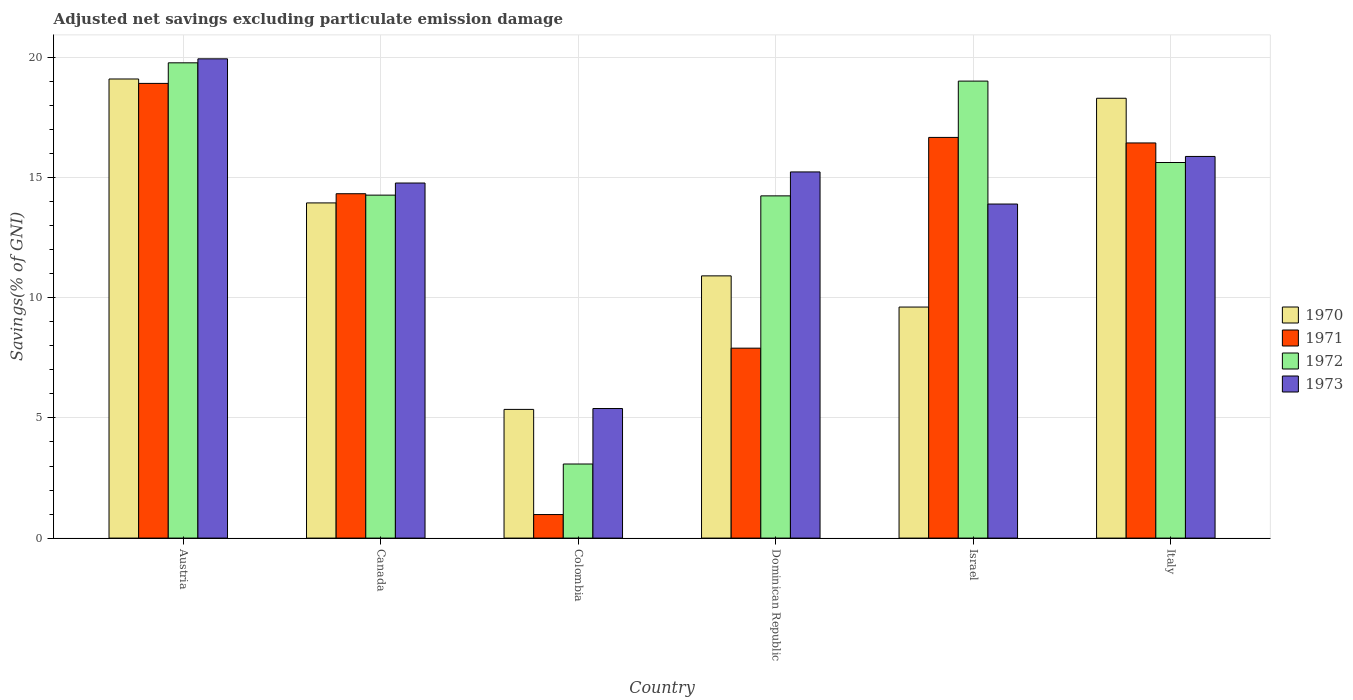How many groups of bars are there?
Ensure brevity in your answer.  6. Are the number of bars per tick equal to the number of legend labels?
Offer a very short reply. Yes. How many bars are there on the 5th tick from the right?
Offer a very short reply. 4. What is the label of the 3rd group of bars from the left?
Offer a terse response. Colombia. What is the adjusted net savings in 1973 in Canada?
Your answer should be very brief. 14.78. Across all countries, what is the maximum adjusted net savings in 1972?
Provide a succinct answer. 19.78. Across all countries, what is the minimum adjusted net savings in 1971?
Your response must be concise. 0.98. In which country was the adjusted net savings in 1973 maximum?
Make the answer very short. Austria. In which country was the adjusted net savings in 1971 minimum?
Offer a terse response. Colombia. What is the total adjusted net savings in 1973 in the graph?
Offer a terse response. 85.14. What is the difference between the adjusted net savings in 1971 in Austria and that in Italy?
Keep it short and to the point. 2.48. What is the difference between the adjusted net savings in 1973 in Canada and the adjusted net savings in 1970 in Italy?
Give a very brief answer. -3.53. What is the average adjusted net savings in 1972 per country?
Make the answer very short. 14.34. What is the difference between the adjusted net savings of/in 1973 and adjusted net savings of/in 1972 in Israel?
Provide a succinct answer. -5.12. In how many countries, is the adjusted net savings in 1972 greater than 6 %?
Give a very brief answer. 5. What is the ratio of the adjusted net savings in 1973 in Dominican Republic to that in Israel?
Your response must be concise. 1.1. What is the difference between the highest and the second highest adjusted net savings in 1972?
Make the answer very short. -0.76. What is the difference between the highest and the lowest adjusted net savings in 1973?
Offer a very short reply. 14.55. In how many countries, is the adjusted net savings in 1972 greater than the average adjusted net savings in 1972 taken over all countries?
Offer a terse response. 3. Is it the case that in every country, the sum of the adjusted net savings in 1972 and adjusted net savings in 1970 is greater than the sum of adjusted net savings in 1971 and adjusted net savings in 1973?
Give a very brief answer. No. What does the 4th bar from the right in Israel represents?
Your answer should be compact. 1970. How many bars are there?
Provide a succinct answer. 24. Are all the bars in the graph horizontal?
Offer a terse response. No. Are the values on the major ticks of Y-axis written in scientific E-notation?
Ensure brevity in your answer.  No. What is the title of the graph?
Offer a terse response. Adjusted net savings excluding particulate emission damage. Does "1982" appear as one of the legend labels in the graph?
Keep it short and to the point. No. What is the label or title of the X-axis?
Make the answer very short. Country. What is the label or title of the Y-axis?
Offer a terse response. Savings(% of GNI). What is the Savings(% of GNI) of 1970 in Austria?
Provide a short and direct response. 19.11. What is the Savings(% of GNI) of 1971 in Austria?
Offer a very short reply. 18.92. What is the Savings(% of GNI) in 1972 in Austria?
Make the answer very short. 19.78. What is the Savings(% of GNI) in 1973 in Austria?
Keep it short and to the point. 19.94. What is the Savings(% of GNI) of 1970 in Canada?
Provide a succinct answer. 13.95. What is the Savings(% of GNI) in 1971 in Canada?
Your answer should be very brief. 14.33. What is the Savings(% of GNI) of 1972 in Canada?
Offer a very short reply. 14.27. What is the Savings(% of GNI) of 1973 in Canada?
Provide a short and direct response. 14.78. What is the Savings(% of GNI) of 1970 in Colombia?
Offer a terse response. 5.36. What is the Savings(% of GNI) in 1971 in Colombia?
Offer a terse response. 0.98. What is the Savings(% of GNI) in 1972 in Colombia?
Give a very brief answer. 3.08. What is the Savings(% of GNI) of 1973 in Colombia?
Provide a short and direct response. 5.39. What is the Savings(% of GNI) of 1970 in Dominican Republic?
Provide a short and direct response. 10.91. What is the Savings(% of GNI) of 1971 in Dominican Republic?
Offer a very short reply. 7.9. What is the Savings(% of GNI) in 1972 in Dominican Republic?
Provide a succinct answer. 14.24. What is the Savings(% of GNI) in 1973 in Dominican Republic?
Your answer should be compact. 15.24. What is the Savings(% of GNI) in 1970 in Israel?
Your answer should be compact. 9.61. What is the Savings(% of GNI) of 1971 in Israel?
Your answer should be very brief. 16.67. What is the Savings(% of GNI) in 1972 in Israel?
Provide a short and direct response. 19.02. What is the Savings(% of GNI) in 1973 in Israel?
Offer a very short reply. 13.9. What is the Savings(% of GNI) in 1970 in Italy?
Ensure brevity in your answer.  18.3. What is the Savings(% of GNI) in 1971 in Italy?
Make the answer very short. 16.44. What is the Savings(% of GNI) of 1972 in Italy?
Give a very brief answer. 15.63. What is the Savings(% of GNI) of 1973 in Italy?
Make the answer very short. 15.88. Across all countries, what is the maximum Savings(% of GNI) in 1970?
Keep it short and to the point. 19.11. Across all countries, what is the maximum Savings(% of GNI) in 1971?
Provide a short and direct response. 18.92. Across all countries, what is the maximum Savings(% of GNI) of 1972?
Provide a succinct answer. 19.78. Across all countries, what is the maximum Savings(% of GNI) in 1973?
Give a very brief answer. 19.94. Across all countries, what is the minimum Savings(% of GNI) of 1970?
Ensure brevity in your answer.  5.36. Across all countries, what is the minimum Savings(% of GNI) of 1971?
Give a very brief answer. 0.98. Across all countries, what is the minimum Savings(% of GNI) in 1972?
Your answer should be compact. 3.08. Across all countries, what is the minimum Savings(% of GNI) of 1973?
Provide a short and direct response. 5.39. What is the total Savings(% of GNI) of 1970 in the graph?
Keep it short and to the point. 77.24. What is the total Savings(% of GNI) in 1971 in the graph?
Your response must be concise. 75.25. What is the total Savings(% of GNI) in 1972 in the graph?
Offer a very short reply. 86.02. What is the total Savings(% of GNI) in 1973 in the graph?
Offer a very short reply. 85.14. What is the difference between the Savings(% of GNI) in 1970 in Austria and that in Canada?
Make the answer very short. 5.16. What is the difference between the Savings(% of GNI) in 1971 in Austria and that in Canada?
Give a very brief answer. 4.59. What is the difference between the Savings(% of GNI) of 1972 in Austria and that in Canada?
Offer a terse response. 5.51. What is the difference between the Savings(% of GNI) of 1973 in Austria and that in Canada?
Provide a succinct answer. 5.17. What is the difference between the Savings(% of GNI) of 1970 in Austria and that in Colombia?
Ensure brevity in your answer.  13.75. What is the difference between the Savings(% of GNI) in 1971 in Austria and that in Colombia?
Your answer should be very brief. 17.94. What is the difference between the Savings(% of GNI) in 1972 in Austria and that in Colombia?
Ensure brevity in your answer.  16.7. What is the difference between the Savings(% of GNI) in 1973 in Austria and that in Colombia?
Provide a short and direct response. 14.55. What is the difference between the Savings(% of GNI) of 1970 in Austria and that in Dominican Republic?
Offer a very short reply. 8.19. What is the difference between the Savings(% of GNI) of 1971 in Austria and that in Dominican Republic?
Your answer should be compact. 11.02. What is the difference between the Savings(% of GNI) of 1972 in Austria and that in Dominican Republic?
Your answer should be very brief. 5.54. What is the difference between the Savings(% of GNI) of 1973 in Austria and that in Dominican Republic?
Provide a short and direct response. 4.71. What is the difference between the Savings(% of GNI) in 1970 in Austria and that in Israel?
Make the answer very short. 9.49. What is the difference between the Savings(% of GNI) of 1971 in Austria and that in Israel?
Your response must be concise. 2.25. What is the difference between the Savings(% of GNI) of 1972 in Austria and that in Israel?
Make the answer very short. 0.76. What is the difference between the Savings(% of GNI) of 1973 in Austria and that in Israel?
Your response must be concise. 6.04. What is the difference between the Savings(% of GNI) of 1970 in Austria and that in Italy?
Provide a short and direct response. 0.8. What is the difference between the Savings(% of GNI) of 1971 in Austria and that in Italy?
Ensure brevity in your answer.  2.48. What is the difference between the Savings(% of GNI) of 1972 in Austria and that in Italy?
Keep it short and to the point. 4.15. What is the difference between the Savings(% of GNI) of 1973 in Austria and that in Italy?
Provide a short and direct response. 4.06. What is the difference between the Savings(% of GNI) in 1970 in Canada and that in Colombia?
Your response must be concise. 8.59. What is the difference between the Savings(% of GNI) in 1971 in Canada and that in Colombia?
Provide a short and direct response. 13.35. What is the difference between the Savings(% of GNI) in 1972 in Canada and that in Colombia?
Provide a succinct answer. 11.19. What is the difference between the Savings(% of GNI) in 1973 in Canada and that in Colombia?
Offer a terse response. 9.38. What is the difference between the Savings(% of GNI) in 1970 in Canada and that in Dominican Republic?
Provide a short and direct response. 3.04. What is the difference between the Savings(% of GNI) in 1971 in Canada and that in Dominican Republic?
Give a very brief answer. 6.43. What is the difference between the Savings(% of GNI) of 1972 in Canada and that in Dominican Republic?
Make the answer very short. 0.03. What is the difference between the Savings(% of GNI) of 1973 in Canada and that in Dominican Republic?
Your response must be concise. -0.46. What is the difference between the Savings(% of GNI) in 1970 in Canada and that in Israel?
Your response must be concise. 4.33. What is the difference between the Savings(% of GNI) in 1971 in Canada and that in Israel?
Give a very brief answer. -2.34. What is the difference between the Savings(% of GNI) in 1972 in Canada and that in Israel?
Ensure brevity in your answer.  -4.75. What is the difference between the Savings(% of GNI) of 1973 in Canada and that in Israel?
Provide a succinct answer. 0.87. What is the difference between the Savings(% of GNI) in 1970 in Canada and that in Italy?
Your response must be concise. -4.36. What is the difference between the Savings(% of GNI) of 1971 in Canada and that in Italy?
Keep it short and to the point. -2.11. What is the difference between the Savings(% of GNI) in 1972 in Canada and that in Italy?
Offer a terse response. -1.36. What is the difference between the Savings(% of GNI) of 1973 in Canada and that in Italy?
Your response must be concise. -1.11. What is the difference between the Savings(% of GNI) in 1970 in Colombia and that in Dominican Republic?
Provide a short and direct response. -5.56. What is the difference between the Savings(% of GNI) in 1971 in Colombia and that in Dominican Republic?
Offer a terse response. -6.92. What is the difference between the Savings(% of GNI) of 1972 in Colombia and that in Dominican Republic?
Make the answer very short. -11.16. What is the difference between the Savings(% of GNI) in 1973 in Colombia and that in Dominican Republic?
Ensure brevity in your answer.  -9.85. What is the difference between the Savings(% of GNI) of 1970 in Colombia and that in Israel?
Provide a short and direct response. -4.26. What is the difference between the Savings(% of GNI) of 1971 in Colombia and that in Israel?
Your response must be concise. -15.7. What is the difference between the Savings(% of GNI) in 1972 in Colombia and that in Israel?
Provide a succinct answer. -15.94. What is the difference between the Savings(% of GNI) in 1973 in Colombia and that in Israel?
Ensure brevity in your answer.  -8.51. What is the difference between the Savings(% of GNI) of 1970 in Colombia and that in Italy?
Provide a succinct answer. -12.95. What is the difference between the Savings(% of GNI) of 1971 in Colombia and that in Italy?
Provide a short and direct response. -15.46. What is the difference between the Savings(% of GNI) of 1972 in Colombia and that in Italy?
Give a very brief answer. -12.55. What is the difference between the Savings(% of GNI) in 1973 in Colombia and that in Italy?
Your response must be concise. -10.49. What is the difference between the Savings(% of GNI) of 1970 in Dominican Republic and that in Israel?
Offer a terse response. 1.3. What is the difference between the Savings(% of GNI) of 1971 in Dominican Republic and that in Israel?
Make the answer very short. -8.77. What is the difference between the Savings(% of GNI) in 1972 in Dominican Republic and that in Israel?
Offer a very short reply. -4.78. What is the difference between the Savings(% of GNI) in 1973 in Dominican Republic and that in Israel?
Ensure brevity in your answer.  1.34. What is the difference between the Savings(% of GNI) of 1970 in Dominican Republic and that in Italy?
Keep it short and to the point. -7.39. What is the difference between the Savings(% of GNI) of 1971 in Dominican Republic and that in Italy?
Offer a very short reply. -8.54. What is the difference between the Savings(% of GNI) of 1972 in Dominican Republic and that in Italy?
Your answer should be compact. -1.39. What is the difference between the Savings(% of GNI) in 1973 in Dominican Republic and that in Italy?
Ensure brevity in your answer.  -0.65. What is the difference between the Savings(% of GNI) of 1970 in Israel and that in Italy?
Offer a terse response. -8.69. What is the difference between the Savings(% of GNI) in 1971 in Israel and that in Italy?
Give a very brief answer. 0.23. What is the difference between the Savings(% of GNI) in 1972 in Israel and that in Italy?
Provide a short and direct response. 3.39. What is the difference between the Savings(% of GNI) in 1973 in Israel and that in Italy?
Offer a very short reply. -1.98. What is the difference between the Savings(% of GNI) of 1970 in Austria and the Savings(% of GNI) of 1971 in Canada?
Ensure brevity in your answer.  4.77. What is the difference between the Savings(% of GNI) of 1970 in Austria and the Savings(% of GNI) of 1972 in Canada?
Provide a short and direct response. 4.83. What is the difference between the Savings(% of GNI) of 1970 in Austria and the Savings(% of GNI) of 1973 in Canada?
Offer a terse response. 4.33. What is the difference between the Savings(% of GNI) of 1971 in Austria and the Savings(% of GNI) of 1972 in Canada?
Your answer should be very brief. 4.65. What is the difference between the Savings(% of GNI) of 1971 in Austria and the Savings(% of GNI) of 1973 in Canada?
Make the answer very short. 4.15. What is the difference between the Savings(% of GNI) in 1972 in Austria and the Savings(% of GNI) in 1973 in Canada?
Ensure brevity in your answer.  5. What is the difference between the Savings(% of GNI) of 1970 in Austria and the Savings(% of GNI) of 1971 in Colombia?
Keep it short and to the point. 18.13. What is the difference between the Savings(% of GNI) of 1970 in Austria and the Savings(% of GNI) of 1972 in Colombia?
Offer a terse response. 16.02. What is the difference between the Savings(% of GNI) of 1970 in Austria and the Savings(% of GNI) of 1973 in Colombia?
Your response must be concise. 13.71. What is the difference between the Savings(% of GNI) of 1971 in Austria and the Savings(% of GNI) of 1972 in Colombia?
Your answer should be very brief. 15.84. What is the difference between the Savings(% of GNI) of 1971 in Austria and the Savings(% of GNI) of 1973 in Colombia?
Provide a short and direct response. 13.53. What is the difference between the Savings(% of GNI) in 1972 in Austria and the Savings(% of GNI) in 1973 in Colombia?
Ensure brevity in your answer.  14.39. What is the difference between the Savings(% of GNI) in 1970 in Austria and the Savings(% of GNI) in 1971 in Dominican Republic?
Your response must be concise. 11.2. What is the difference between the Savings(% of GNI) in 1970 in Austria and the Savings(% of GNI) in 1972 in Dominican Republic?
Make the answer very short. 4.86. What is the difference between the Savings(% of GNI) of 1970 in Austria and the Savings(% of GNI) of 1973 in Dominican Republic?
Keep it short and to the point. 3.87. What is the difference between the Savings(% of GNI) in 1971 in Austria and the Savings(% of GNI) in 1972 in Dominican Republic?
Provide a short and direct response. 4.68. What is the difference between the Savings(% of GNI) of 1971 in Austria and the Savings(% of GNI) of 1973 in Dominican Republic?
Offer a very short reply. 3.68. What is the difference between the Savings(% of GNI) of 1972 in Austria and the Savings(% of GNI) of 1973 in Dominican Republic?
Give a very brief answer. 4.54. What is the difference between the Savings(% of GNI) of 1970 in Austria and the Savings(% of GNI) of 1971 in Israel?
Make the answer very short. 2.43. What is the difference between the Savings(% of GNI) in 1970 in Austria and the Savings(% of GNI) in 1972 in Israel?
Your answer should be very brief. 0.09. What is the difference between the Savings(% of GNI) of 1970 in Austria and the Savings(% of GNI) of 1973 in Israel?
Your answer should be very brief. 5.2. What is the difference between the Savings(% of GNI) of 1971 in Austria and the Savings(% of GNI) of 1972 in Israel?
Keep it short and to the point. -0.1. What is the difference between the Savings(% of GNI) of 1971 in Austria and the Savings(% of GNI) of 1973 in Israel?
Offer a very short reply. 5.02. What is the difference between the Savings(% of GNI) of 1972 in Austria and the Savings(% of GNI) of 1973 in Israel?
Give a very brief answer. 5.88. What is the difference between the Savings(% of GNI) in 1970 in Austria and the Savings(% of GNI) in 1971 in Italy?
Make the answer very short. 2.66. What is the difference between the Savings(% of GNI) of 1970 in Austria and the Savings(% of GNI) of 1972 in Italy?
Make the answer very short. 3.48. What is the difference between the Savings(% of GNI) in 1970 in Austria and the Savings(% of GNI) in 1973 in Italy?
Your answer should be compact. 3.22. What is the difference between the Savings(% of GNI) of 1971 in Austria and the Savings(% of GNI) of 1972 in Italy?
Offer a very short reply. 3.29. What is the difference between the Savings(% of GNI) in 1971 in Austria and the Savings(% of GNI) in 1973 in Italy?
Your response must be concise. 3.04. What is the difference between the Savings(% of GNI) of 1972 in Austria and the Savings(% of GNI) of 1973 in Italy?
Give a very brief answer. 3.9. What is the difference between the Savings(% of GNI) in 1970 in Canada and the Savings(% of GNI) in 1971 in Colombia?
Give a very brief answer. 12.97. What is the difference between the Savings(% of GNI) of 1970 in Canada and the Savings(% of GNI) of 1972 in Colombia?
Ensure brevity in your answer.  10.87. What is the difference between the Savings(% of GNI) in 1970 in Canada and the Savings(% of GNI) in 1973 in Colombia?
Give a very brief answer. 8.56. What is the difference between the Savings(% of GNI) in 1971 in Canada and the Savings(% of GNI) in 1972 in Colombia?
Give a very brief answer. 11.25. What is the difference between the Savings(% of GNI) of 1971 in Canada and the Savings(% of GNI) of 1973 in Colombia?
Your answer should be compact. 8.94. What is the difference between the Savings(% of GNI) of 1972 in Canada and the Savings(% of GNI) of 1973 in Colombia?
Offer a terse response. 8.88. What is the difference between the Savings(% of GNI) of 1970 in Canada and the Savings(% of GNI) of 1971 in Dominican Republic?
Provide a short and direct response. 6.05. What is the difference between the Savings(% of GNI) in 1970 in Canada and the Savings(% of GNI) in 1972 in Dominican Republic?
Your answer should be compact. -0.29. What is the difference between the Savings(% of GNI) in 1970 in Canada and the Savings(% of GNI) in 1973 in Dominican Republic?
Your answer should be compact. -1.29. What is the difference between the Savings(% of GNI) of 1971 in Canada and the Savings(% of GNI) of 1972 in Dominican Republic?
Your answer should be very brief. 0.09. What is the difference between the Savings(% of GNI) of 1971 in Canada and the Savings(% of GNI) of 1973 in Dominican Republic?
Provide a succinct answer. -0.91. What is the difference between the Savings(% of GNI) of 1972 in Canada and the Savings(% of GNI) of 1973 in Dominican Republic?
Keep it short and to the point. -0.97. What is the difference between the Savings(% of GNI) of 1970 in Canada and the Savings(% of GNI) of 1971 in Israel?
Ensure brevity in your answer.  -2.73. What is the difference between the Savings(% of GNI) in 1970 in Canada and the Savings(% of GNI) in 1972 in Israel?
Provide a short and direct response. -5.07. What is the difference between the Savings(% of GNI) in 1970 in Canada and the Savings(% of GNI) in 1973 in Israel?
Your answer should be compact. 0.05. What is the difference between the Savings(% of GNI) in 1971 in Canada and the Savings(% of GNI) in 1972 in Israel?
Make the answer very short. -4.69. What is the difference between the Savings(% of GNI) in 1971 in Canada and the Savings(% of GNI) in 1973 in Israel?
Your response must be concise. 0.43. What is the difference between the Savings(% of GNI) of 1972 in Canada and the Savings(% of GNI) of 1973 in Israel?
Give a very brief answer. 0.37. What is the difference between the Savings(% of GNI) of 1970 in Canada and the Savings(% of GNI) of 1971 in Italy?
Give a very brief answer. -2.5. What is the difference between the Savings(% of GNI) of 1970 in Canada and the Savings(% of GNI) of 1972 in Italy?
Your answer should be very brief. -1.68. What is the difference between the Savings(% of GNI) of 1970 in Canada and the Savings(% of GNI) of 1973 in Italy?
Your answer should be compact. -1.93. What is the difference between the Savings(% of GNI) of 1971 in Canada and the Savings(% of GNI) of 1972 in Italy?
Ensure brevity in your answer.  -1.3. What is the difference between the Savings(% of GNI) in 1971 in Canada and the Savings(% of GNI) in 1973 in Italy?
Your response must be concise. -1.55. What is the difference between the Savings(% of GNI) in 1972 in Canada and the Savings(% of GNI) in 1973 in Italy?
Give a very brief answer. -1.61. What is the difference between the Savings(% of GNI) in 1970 in Colombia and the Savings(% of GNI) in 1971 in Dominican Republic?
Provide a succinct answer. -2.55. What is the difference between the Savings(% of GNI) in 1970 in Colombia and the Savings(% of GNI) in 1972 in Dominican Republic?
Offer a very short reply. -8.89. What is the difference between the Savings(% of GNI) in 1970 in Colombia and the Savings(% of GNI) in 1973 in Dominican Republic?
Offer a very short reply. -9.88. What is the difference between the Savings(% of GNI) of 1971 in Colombia and the Savings(% of GNI) of 1972 in Dominican Republic?
Offer a terse response. -13.26. What is the difference between the Savings(% of GNI) of 1971 in Colombia and the Savings(% of GNI) of 1973 in Dominican Republic?
Provide a short and direct response. -14.26. What is the difference between the Savings(% of GNI) of 1972 in Colombia and the Savings(% of GNI) of 1973 in Dominican Republic?
Your response must be concise. -12.15. What is the difference between the Savings(% of GNI) of 1970 in Colombia and the Savings(% of GNI) of 1971 in Israel?
Your answer should be very brief. -11.32. What is the difference between the Savings(% of GNI) of 1970 in Colombia and the Savings(% of GNI) of 1972 in Israel?
Your answer should be compact. -13.66. What is the difference between the Savings(% of GNI) in 1970 in Colombia and the Savings(% of GNI) in 1973 in Israel?
Offer a terse response. -8.55. What is the difference between the Savings(% of GNI) of 1971 in Colombia and the Savings(% of GNI) of 1972 in Israel?
Your answer should be very brief. -18.04. What is the difference between the Savings(% of GNI) of 1971 in Colombia and the Savings(% of GNI) of 1973 in Israel?
Your answer should be very brief. -12.92. What is the difference between the Savings(% of GNI) of 1972 in Colombia and the Savings(% of GNI) of 1973 in Israel?
Offer a terse response. -10.82. What is the difference between the Savings(% of GNI) of 1970 in Colombia and the Savings(% of GNI) of 1971 in Italy?
Your response must be concise. -11.09. What is the difference between the Savings(% of GNI) of 1970 in Colombia and the Savings(% of GNI) of 1972 in Italy?
Your response must be concise. -10.27. What is the difference between the Savings(% of GNI) of 1970 in Colombia and the Savings(% of GNI) of 1973 in Italy?
Make the answer very short. -10.53. What is the difference between the Savings(% of GNI) in 1971 in Colombia and the Savings(% of GNI) in 1972 in Italy?
Offer a terse response. -14.65. What is the difference between the Savings(% of GNI) in 1971 in Colombia and the Savings(% of GNI) in 1973 in Italy?
Provide a succinct answer. -14.9. What is the difference between the Savings(% of GNI) of 1972 in Colombia and the Savings(% of GNI) of 1973 in Italy?
Your answer should be very brief. -12.8. What is the difference between the Savings(% of GNI) in 1970 in Dominican Republic and the Savings(% of GNI) in 1971 in Israel?
Offer a very short reply. -5.76. What is the difference between the Savings(% of GNI) of 1970 in Dominican Republic and the Savings(% of GNI) of 1972 in Israel?
Provide a short and direct response. -8.11. What is the difference between the Savings(% of GNI) of 1970 in Dominican Republic and the Savings(% of GNI) of 1973 in Israel?
Your response must be concise. -2.99. What is the difference between the Savings(% of GNI) of 1971 in Dominican Republic and the Savings(% of GNI) of 1972 in Israel?
Your response must be concise. -11.11. What is the difference between the Savings(% of GNI) of 1971 in Dominican Republic and the Savings(% of GNI) of 1973 in Israel?
Keep it short and to the point. -6. What is the difference between the Savings(% of GNI) of 1972 in Dominican Republic and the Savings(% of GNI) of 1973 in Israel?
Offer a very short reply. 0.34. What is the difference between the Savings(% of GNI) in 1970 in Dominican Republic and the Savings(% of GNI) in 1971 in Italy?
Ensure brevity in your answer.  -5.53. What is the difference between the Savings(% of GNI) of 1970 in Dominican Republic and the Savings(% of GNI) of 1972 in Italy?
Provide a short and direct response. -4.72. What is the difference between the Savings(% of GNI) in 1970 in Dominican Republic and the Savings(% of GNI) in 1973 in Italy?
Provide a short and direct response. -4.97. What is the difference between the Savings(% of GNI) in 1971 in Dominican Republic and the Savings(% of GNI) in 1972 in Italy?
Offer a very short reply. -7.73. What is the difference between the Savings(% of GNI) of 1971 in Dominican Republic and the Savings(% of GNI) of 1973 in Italy?
Your response must be concise. -7.98. What is the difference between the Savings(% of GNI) in 1972 in Dominican Republic and the Savings(% of GNI) in 1973 in Italy?
Your answer should be compact. -1.64. What is the difference between the Savings(% of GNI) in 1970 in Israel and the Savings(% of GNI) in 1971 in Italy?
Give a very brief answer. -6.83. What is the difference between the Savings(% of GNI) of 1970 in Israel and the Savings(% of GNI) of 1972 in Italy?
Offer a very short reply. -6.02. What is the difference between the Savings(% of GNI) in 1970 in Israel and the Savings(% of GNI) in 1973 in Italy?
Offer a terse response. -6.27. What is the difference between the Savings(% of GNI) of 1971 in Israel and the Savings(% of GNI) of 1972 in Italy?
Your answer should be compact. 1.04. What is the difference between the Savings(% of GNI) of 1971 in Israel and the Savings(% of GNI) of 1973 in Italy?
Your answer should be very brief. 0.79. What is the difference between the Savings(% of GNI) of 1972 in Israel and the Savings(% of GNI) of 1973 in Italy?
Your response must be concise. 3.14. What is the average Savings(% of GNI) of 1970 per country?
Make the answer very short. 12.87. What is the average Savings(% of GNI) of 1971 per country?
Your response must be concise. 12.54. What is the average Savings(% of GNI) in 1972 per country?
Provide a short and direct response. 14.34. What is the average Savings(% of GNI) of 1973 per country?
Offer a very short reply. 14.19. What is the difference between the Savings(% of GNI) in 1970 and Savings(% of GNI) in 1971 in Austria?
Make the answer very short. 0.18. What is the difference between the Savings(% of GNI) of 1970 and Savings(% of GNI) of 1972 in Austria?
Provide a short and direct response. -0.67. What is the difference between the Savings(% of GNI) of 1970 and Savings(% of GNI) of 1973 in Austria?
Offer a terse response. -0.84. What is the difference between the Savings(% of GNI) in 1971 and Savings(% of GNI) in 1972 in Austria?
Your response must be concise. -0.86. What is the difference between the Savings(% of GNI) of 1971 and Savings(% of GNI) of 1973 in Austria?
Your answer should be very brief. -1.02. What is the difference between the Savings(% of GNI) in 1972 and Savings(% of GNI) in 1973 in Austria?
Ensure brevity in your answer.  -0.17. What is the difference between the Savings(% of GNI) in 1970 and Savings(% of GNI) in 1971 in Canada?
Give a very brief answer. -0.38. What is the difference between the Savings(% of GNI) of 1970 and Savings(% of GNI) of 1972 in Canada?
Ensure brevity in your answer.  -0.32. What is the difference between the Savings(% of GNI) of 1970 and Savings(% of GNI) of 1973 in Canada?
Give a very brief answer. -0.83. What is the difference between the Savings(% of GNI) of 1971 and Savings(% of GNI) of 1972 in Canada?
Make the answer very short. 0.06. What is the difference between the Savings(% of GNI) in 1971 and Savings(% of GNI) in 1973 in Canada?
Your response must be concise. -0.45. What is the difference between the Savings(% of GNI) of 1972 and Savings(% of GNI) of 1973 in Canada?
Give a very brief answer. -0.5. What is the difference between the Savings(% of GNI) of 1970 and Savings(% of GNI) of 1971 in Colombia?
Your answer should be very brief. 4.38. What is the difference between the Savings(% of GNI) in 1970 and Savings(% of GNI) in 1972 in Colombia?
Make the answer very short. 2.27. What is the difference between the Savings(% of GNI) of 1970 and Savings(% of GNI) of 1973 in Colombia?
Your answer should be compact. -0.04. What is the difference between the Savings(% of GNI) in 1971 and Savings(% of GNI) in 1972 in Colombia?
Give a very brief answer. -2.1. What is the difference between the Savings(% of GNI) of 1971 and Savings(% of GNI) of 1973 in Colombia?
Provide a succinct answer. -4.41. What is the difference between the Savings(% of GNI) of 1972 and Savings(% of GNI) of 1973 in Colombia?
Offer a very short reply. -2.31. What is the difference between the Savings(% of GNI) in 1970 and Savings(% of GNI) in 1971 in Dominican Republic?
Give a very brief answer. 3.01. What is the difference between the Savings(% of GNI) in 1970 and Savings(% of GNI) in 1972 in Dominican Republic?
Make the answer very short. -3.33. What is the difference between the Savings(% of GNI) of 1970 and Savings(% of GNI) of 1973 in Dominican Republic?
Give a very brief answer. -4.33. What is the difference between the Savings(% of GNI) of 1971 and Savings(% of GNI) of 1972 in Dominican Republic?
Your answer should be compact. -6.34. What is the difference between the Savings(% of GNI) in 1971 and Savings(% of GNI) in 1973 in Dominican Republic?
Give a very brief answer. -7.33. What is the difference between the Savings(% of GNI) of 1972 and Savings(% of GNI) of 1973 in Dominican Republic?
Make the answer very short. -1. What is the difference between the Savings(% of GNI) in 1970 and Savings(% of GNI) in 1971 in Israel?
Your answer should be very brief. -7.06. What is the difference between the Savings(% of GNI) of 1970 and Savings(% of GNI) of 1972 in Israel?
Offer a terse response. -9.4. What is the difference between the Savings(% of GNI) in 1970 and Savings(% of GNI) in 1973 in Israel?
Offer a very short reply. -4.29. What is the difference between the Savings(% of GNI) of 1971 and Savings(% of GNI) of 1972 in Israel?
Give a very brief answer. -2.34. What is the difference between the Savings(% of GNI) of 1971 and Savings(% of GNI) of 1973 in Israel?
Ensure brevity in your answer.  2.77. What is the difference between the Savings(% of GNI) of 1972 and Savings(% of GNI) of 1973 in Israel?
Give a very brief answer. 5.12. What is the difference between the Savings(% of GNI) in 1970 and Savings(% of GNI) in 1971 in Italy?
Keep it short and to the point. 1.86. What is the difference between the Savings(% of GNI) in 1970 and Savings(% of GNI) in 1972 in Italy?
Your answer should be compact. 2.67. What is the difference between the Savings(% of GNI) in 1970 and Savings(% of GNI) in 1973 in Italy?
Keep it short and to the point. 2.42. What is the difference between the Savings(% of GNI) of 1971 and Savings(% of GNI) of 1972 in Italy?
Offer a terse response. 0.81. What is the difference between the Savings(% of GNI) in 1971 and Savings(% of GNI) in 1973 in Italy?
Your answer should be compact. 0.56. What is the difference between the Savings(% of GNI) of 1972 and Savings(% of GNI) of 1973 in Italy?
Keep it short and to the point. -0.25. What is the ratio of the Savings(% of GNI) of 1970 in Austria to that in Canada?
Offer a very short reply. 1.37. What is the ratio of the Savings(% of GNI) in 1971 in Austria to that in Canada?
Keep it short and to the point. 1.32. What is the ratio of the Savings(% of GNI) of 1972 in Austria to that in Canada?
Your response must be concise. 1.39. What is the ratio of the Savings(% of GNI) in 1973 in Austria to that in Canada?
Make the answer very short. 1.35. What is the ratio of the Savings(% of GNI) of 1970 in Austria to that in Colombia?
Your answer should be compact. 3.57. What is the ratio of the Savings(% of GNI) of 1971 in Austria to that in Colombia?
Your answer should be very brief. 19.32. What is the ratio of the Savings(% of GNI) in 1972 in Austria to that in Colombia?
Give a very brief answer. 6.42. What is the ratio of the Savings(% of GNI) of 1973 in Austria to that in Colombia?
Give a very brief answer. 3.7. What is the ratio of the Savings(% of GNI) of 1970 in Austria to that in Dominican Republic?
Make the answer very short. 1.75. What is the ratio of the Savings(% of GNI) in 1971 in Austria to that in Dominican Republic?
Provide a short and direct response. 2.39. What is the ratio of the Savings(% of GNI) in 1972 in Austria to that in Dominican Republic?
Provide a succinct answer. 1.39. What is the ratio of the Savings(% of GNI) in 1973 in Austria to that in Dominican Republic?
Provide a short and direct response. 1.31. What is the ratio of the Savings(% of GNI) in 1970 in Austria to that in Israel?
Your answer should be very brief. 1.99. What is the ratio of the Savings(% of GNI) in 1971 in Austria to that in Israel?
Provide a short and direct response. 1.13. What is the ratio of the Savings(% of GNI) of 1973 in Austria to that in Israel?
Make the answer very short. 1.43. What is the ratio of the Savings(% of GNI) of 1970 in Austria to that in Italy?
Offer a very short reply. 1.04. What is the ratio of the Savings(% of GNI) in 1971 in Austria to that in Italy?
Give a very brief answer. 1.15. What is the ratio of the Savings(% of GNI) of 1972 in Austria to that in Italy?
Ensure brevity in your answer.  1.27. What is the ratio of the Savings(% of GNI) of 1973 in Austria to that in Italy?
Make the answer very short. 1.26. What is the ratio of the Savings(% of GNI) of 1970 in Canada to that in Colombia?
Give a very brief answer. 2.6. What is the ratio of the Savings(% of GNI) of 1971 in Canada to that in Colombia?
Provide a succinct answer. 14.64. What is the ratio of the Savings(% of GNI) in 1972 in Canada to that in Colombia?
Your answer should be compact. 4.63. What is the ratio of the Savings(% of GNI) of 1973 in Canada to that in Colombia?
Make the answer very short. 2.74. What is the ratio of the Savings(% of GNI) of 1970 in Canada to that in Dominican Republic?
Keep it short and to the point. 1.28. What is the ratio of the Savings(% of GNI) of 1971 in Canada to that in Dominican Republic?
Your answer should be compact. 1.81. What is the ratio of the Savings(% of GNI) of 1972 in Canada to that in Dominican Republic?
Give a very brief answer. 1. What is the ratio of the Savings(% of GNI) in 1973 in Canada to that in Dominican Republic?
Provide a succinct answer. 0.97. What is the ratio of the Savings(% of GNI) in 1970 in Canada to that in Israel?
Offer a very short reply. 1.45. What is the ratio of the Savings(% of GNI) of 1971 in Canada to that in Israel?
Your response must be concise. 0.86. What is the ratio of the Savings(% of GNI) of 1972 in Canada to that in Israel?
Offer a terse response. 0.75. What is the ratio of the Savings(% of GNI) in 1973 in Canada to that in Israel?
Ensure brevity in your answer.  1.06. What is the ratio of the Savings(% of GNI) in 1970 in Canada to that in Italy?
Make the answer very short. 0.76. What is the ratio of the Savings(% of GNI) in 1971 in Canada to that in Italy?
Provide a short and direct response. 0.87. What is the ratio of the Savings(% of GNI) of 1972 in Canada to that in Italy?
Provide a short and direct response. 0.91. What is the ratio of the Savings(% of GNI) of 1973 in Canada to that in Italy?
Offer a terse response. 0.93. What is the ratio of the Savings(% of GNI) of 1970 in Colombia to that in Dominican Republic?
Provide a short and direct response. 0.49. What is the ratio of the Savings(% of GNI) of 1971 in Colombia to that in Dominican Republic?
Ensure brevity in your answer.  0.12. What is the ratio of the Savings(% of GNI) of 1972 in Colombia to that in Dominican Republic?
Make the answer very short. 0.22. What is the ratio of the Savings(% of GNI) in 1973 in Colombia to that in Dominican Republic?
Your response must be concise. 0.35. What is the ratio of the Savings(% of GNI) of 1970 in Colombia to that in Israel?
Provide a succinct answer. 0.56. What is the ratio of the Savings(% of GNI) in 1971 in Colombia to that in Israel?
Your answer should be very brief. 0.06. What is the ratio of the Savings(% of GNI) in 1972 in Colombia to that in Israel?
Your answer should be compact. 0.16. What is the ratio of the Savings(% of GNI) in 1973 in Colombia to that in Israel?
Offer a terse response. 0.39. What is the ratio of the Savings(% of GNI) in 1970 in Colombia to that in Italy?
Provide a succinct answer. 0.29. What is the ratio of the Savings(% of GNI) in 1971 in Colombia to that in Italy?
Keep it short and to the point. 0.06. What is the ratio of the Savings(% of GNI) of 1972 in Colombia to that in Italy?
Your response must be concise. 0.2. What is the ratio of the Savings(% of GNI) in 1973 in Colombia to that in Italy?
Make the answer very short. 0.34. What is the ratio of the Savings(% of GNI) of 1970 in Dominican Republic to that in Israel?
Your answer should be compact. 1.14. What is the ratio of the Savings(% of GNI) of 1971 in Dominican Republic to that in Israel?
Ensure brevity in your answer.  0.47. What is the ratio of the Savings(% of GNI) in 1972 in Dominican Republic to that in Israel?
Make the answer very short. 0.75. What is the ratio of the Savings(% of GNI) in 1973 in Dominican Republic to that in Israel?
Provide a short and direct response. 1.1. What is the ratio of the Savings(% of GNI) of 1970 in Dominican Republic to that in Italy?
Give a very brief answer. 0.6. What is the ratio of the Savings(% of GNI) in 1971 in Dominican Republic to that in Italy?
Make the answer very short. 0.48. What is the ratio of the Savings(% of GNI) of 1972 in Dominican Republic to that in Italy?
Provide a succinct answer. 0.91. What is the ratio of the Savings(% of GNI) of 1973 in Dominican Republic to that in Italy?
Your answer should be compact. 0.96. What is the ratio of the Savings(% of GNI) in 1970 in Israel to that in Italy?
Make the answer very short. 0.53. What is the ratio of the Savings(% of GNI) in 1972 in Israel to that in Italy?
Give a very brief answer. 1.22. What is the ratio of the Savings(% of GNI) of 1973 in Israel to that in Italy?
Offer a terse response. 0.88. What is the difference between the highest and the second highest Savings(% of GNI) of 1970?
Provide a short and direct response. 0.8. What is the difference between the highest and the second highest Savings(% of GNI) of 1971?
Keep it short and to the point. 2.25. What is the difference between the highest and the second highest Savings(% of GNI) in 1972?
Give a very brief answer. 0.76. What is the difference between the highest and the second highest Savings(% of GNI) of 1973?
Provide a succinct answer. 4.06. What is the difference between the highest and the lowest Savings(% of GNI) in 1970?
Your answer should be compact. 13.75. What is the difference between the highest and the lowest Savings(% of GNI) in 1971?
Ensure brevity in your answer.  17.94. What is the difference between the highest and the lowest Savings(% of GNI) of 1972?
Make the answer very short. 16.7. What is the difference between the highest and the lowest Savings(% of GNI) in 1973?
Offer a very short reply. 14.55. 